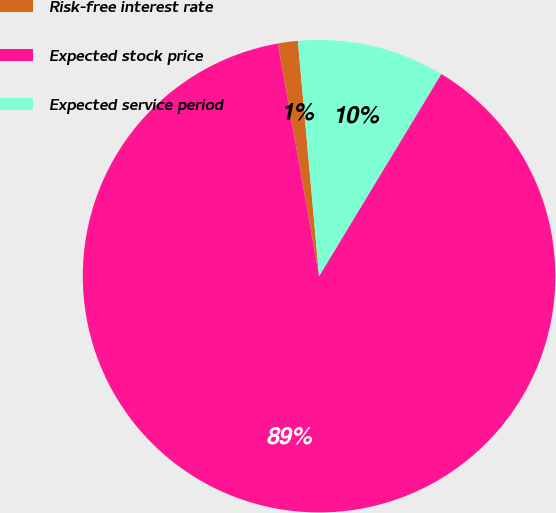Convert chart. <chart><loc_0><loc_0><loc_500><loc_500><pie_chart><fcel>Risk-free interest rate<fcel>Expected stock price<fcel>Expected service period<nl><fcel>1.36%<fcel>88.56%<fcel>10.08%<nl></chart> 